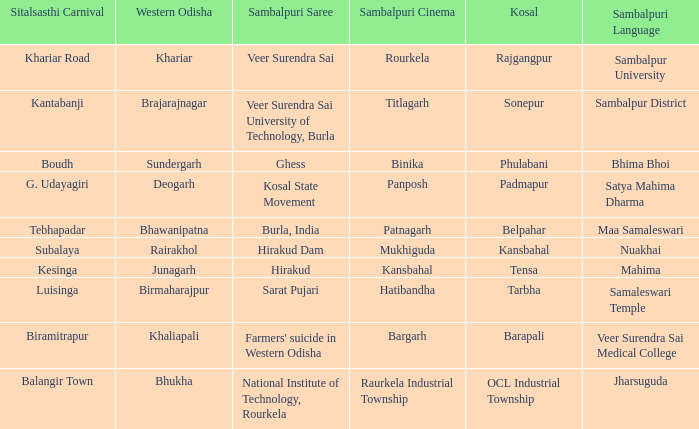What is the sitalsasthi carnival with sonepur as kosal? Kantabanji. 